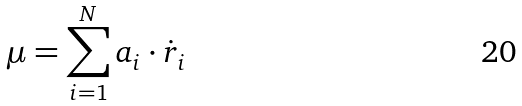Convert formula to latex. <formula><loc_0><loc_0><loc_500><loc_500>\mu = \sum _ { i = 1 } ^ { N } a _ { i } \cdot \dot { r } _ { i }</formula> 